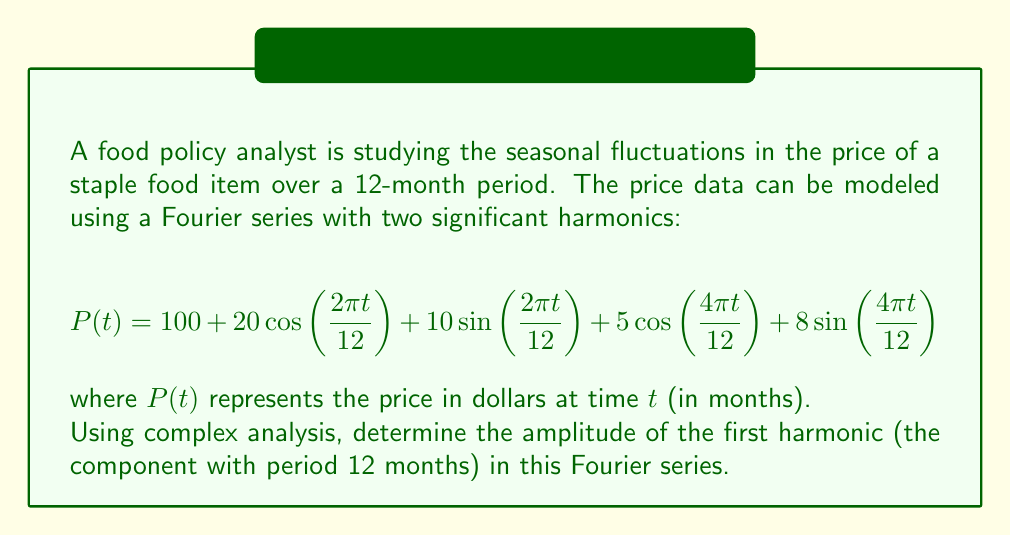Can you answer this question? To solve this problem, we'll use complex analysis techniques to rewrite the Fourier series in exponential form and then identify the amplitude of the first harmonic.

1) First, recall Euler's formula: $e^{ix} = \cos(x) + i\sin(x)$

2) We can rewrite the cosine and sine terms of the first harmonic using complex exponentials:

   $20\cos\left(\frac{2\pi t}{12}\right) + 10\sin\left(\frac{2\pi t}{12}\right) = 10(2\cos\left(\frac{2\pi t}{12}\right) + i\sin\left(\frac{2\pi t}{12}\right)) + 10(2\cos\left(\frac{2\pi t}{12}\right) - i\sin\left(\frac{2\pi t}{12}\right))$

3) Using Euler's formula, this becomes:

   $10e^{i\frac{2\pi t}{12}} + 10e^{-i\frac{2\pi t}{12}}$

4) Let $z = e^{i\frac{2\pi t}{12}}$. Then the first harmonic can be written as $10z + 10\bar{z}$, where $\bar{z}$ is the complex conjugate of $z$.

5) The amplitude of this harmonic is the modulus of the complex coefficient. In this case, it's $|10 + 10i| = \sqrt{10^2 + 10^2} = 10\sqrt{2}$.

Therefore, the amplitude of the first harmonic is $10\sqrt{2}$ dollars.
Answer: $10\sqrt{2}$ dollars 